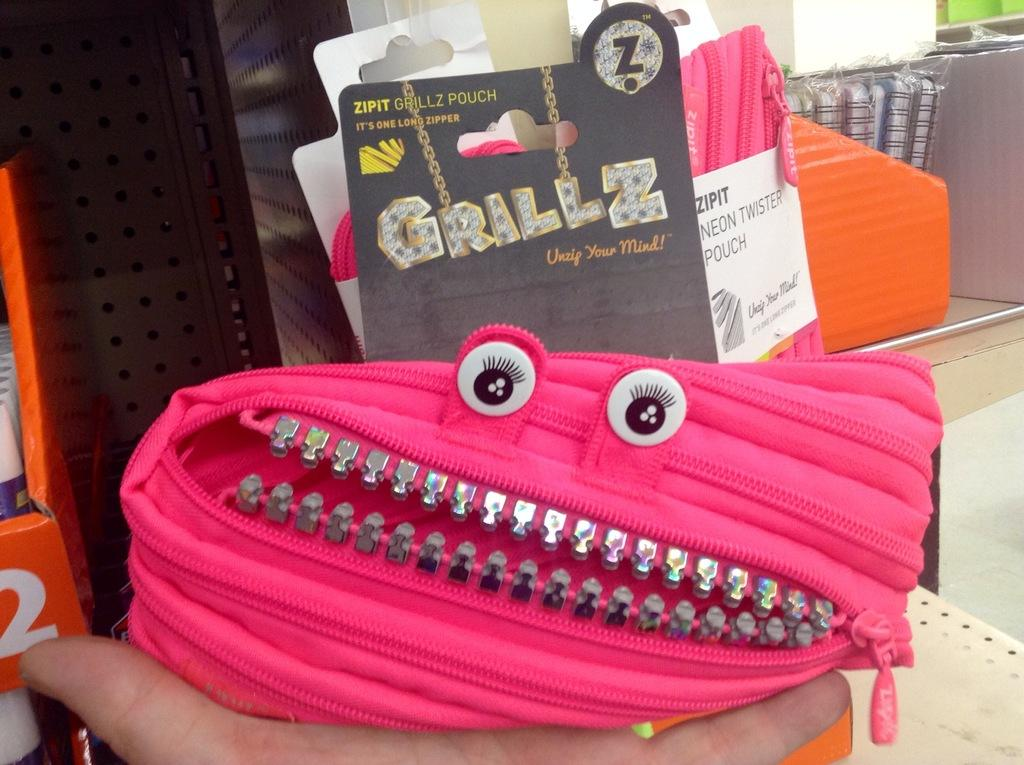What is the main subject of the image? The main subject of the image is a person's hand holding objects. Can you describe the objects being held by the hand? Among the objects held by the hand, there is a pouch. Are there any objects with text in the image? Yes, there are objects with text in the image. Are there any objects with images in the image? Yes, there are objects with images in the image. Can you describe the objects in the background of the image? There are a few objects in the background of the image. What type of station is depicted in the image? There is no station depicted in the image; it features a person's hand holding objects. What verse can be heard being recited in the image? There is no verse being recited in the image; it only shows a person's hand holding objects. 